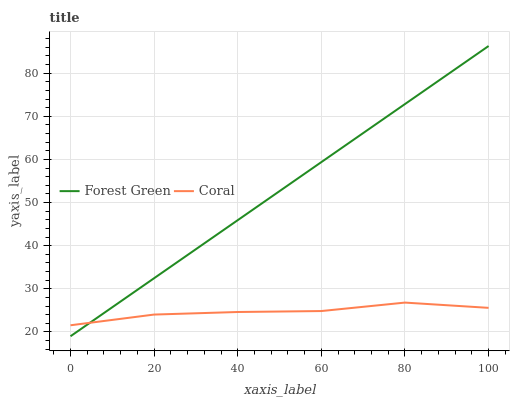Does Coral have the minimum area under the curve?
Answer yes or no. Yes. Does Forest Green have the maximum area under the curve?
Answer yes or no. Yes. Does Coral have the maximum area under the curve?
Answer yes or no. No. Is Forest Green the smoothest?
Answer yes or no. Yes. Is Coral the roughest?
Answer yes or no. Yes. Is Coral the smoothest?
Answer yes or no. No. Does Forest Green have the lowest value?
Answer yes or no. Yes. Does Coral have the lowest value?
Answer yes or no. No. Does Forest Green have the highest value?
Answer yes or no. Yes. Does Coral have the highest value?
Answer yes or no. No. Does Coral intersect Forest Green?
Answer yes or no. Yes. Is Coral less than Forest Green?
Answer yes or no. No. Is Coral greater than Forest Green?
Answer yes or no. No. 